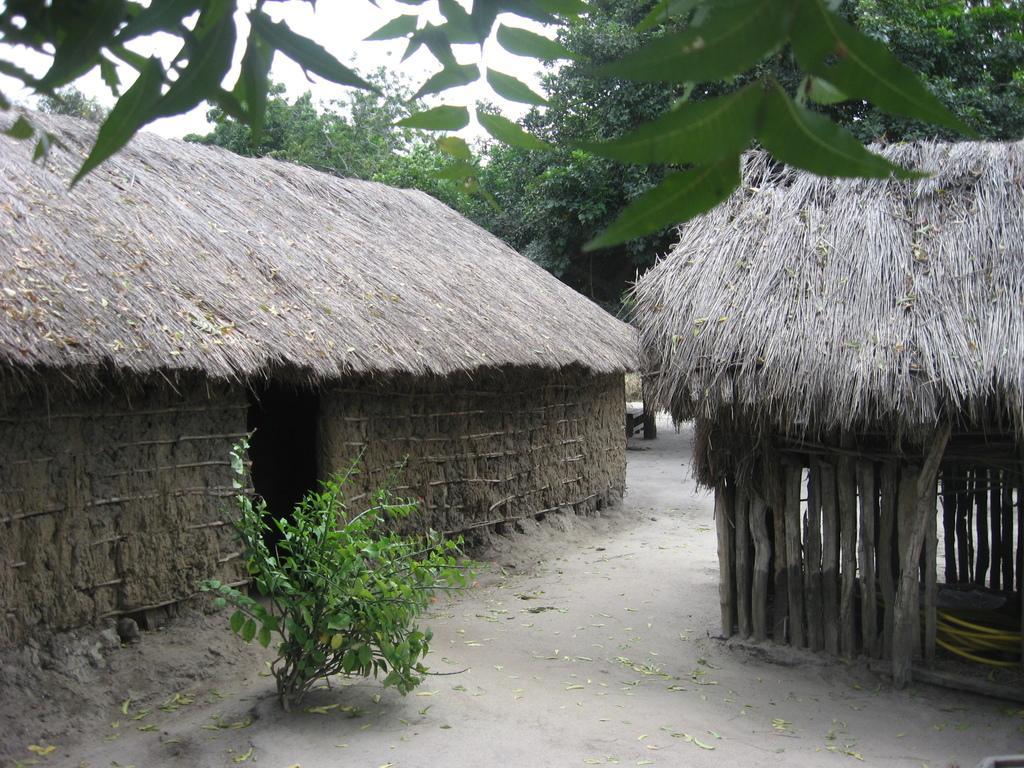Can you describe this image briefly? There are two huts. In front of the hut there is a plant. In the back there are trees and sky. 